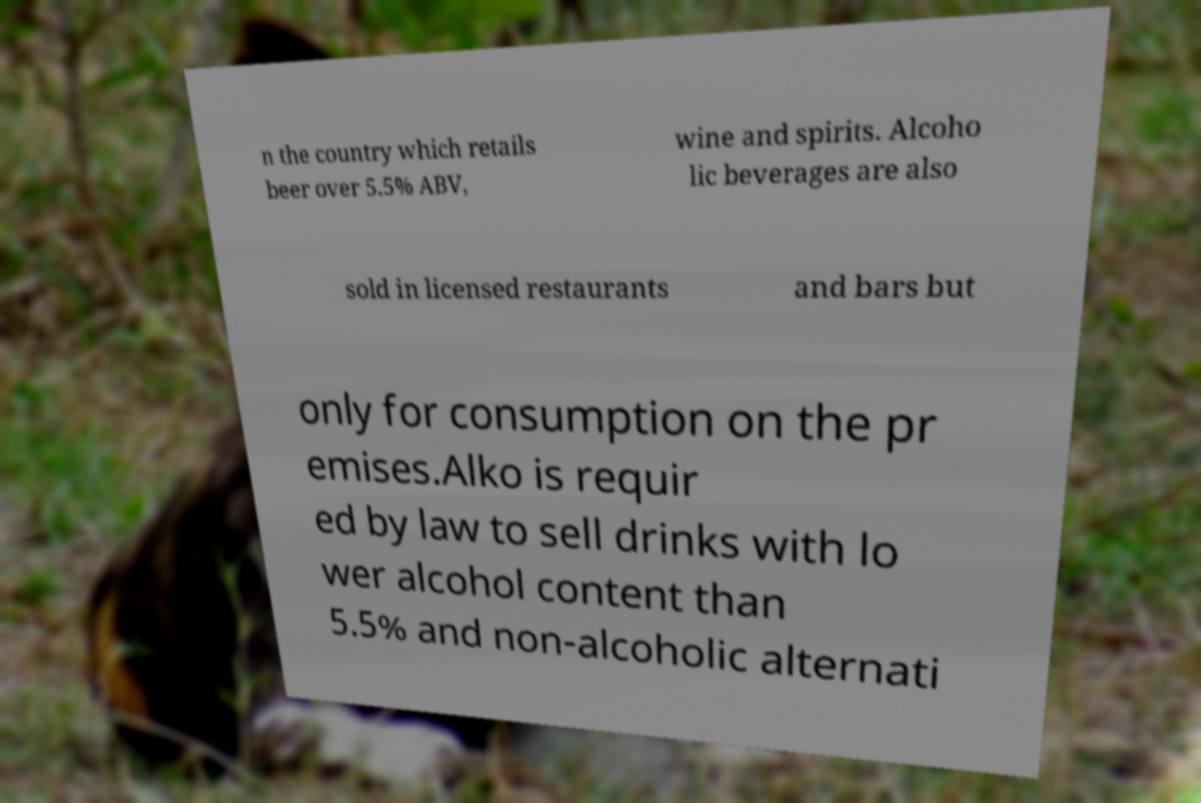I need the written content from this picture converted into text. Can you do that? n the country which retails beer over 5.5% ABV, wine and spirits. Alcoho lic beverages are also sold in licensed restaurants and bars but only for consumption on the pr emises.Alko is requir ed by law to sell drinks with lo wer alcohol content than 5.5% and non-alcoholic alternati 